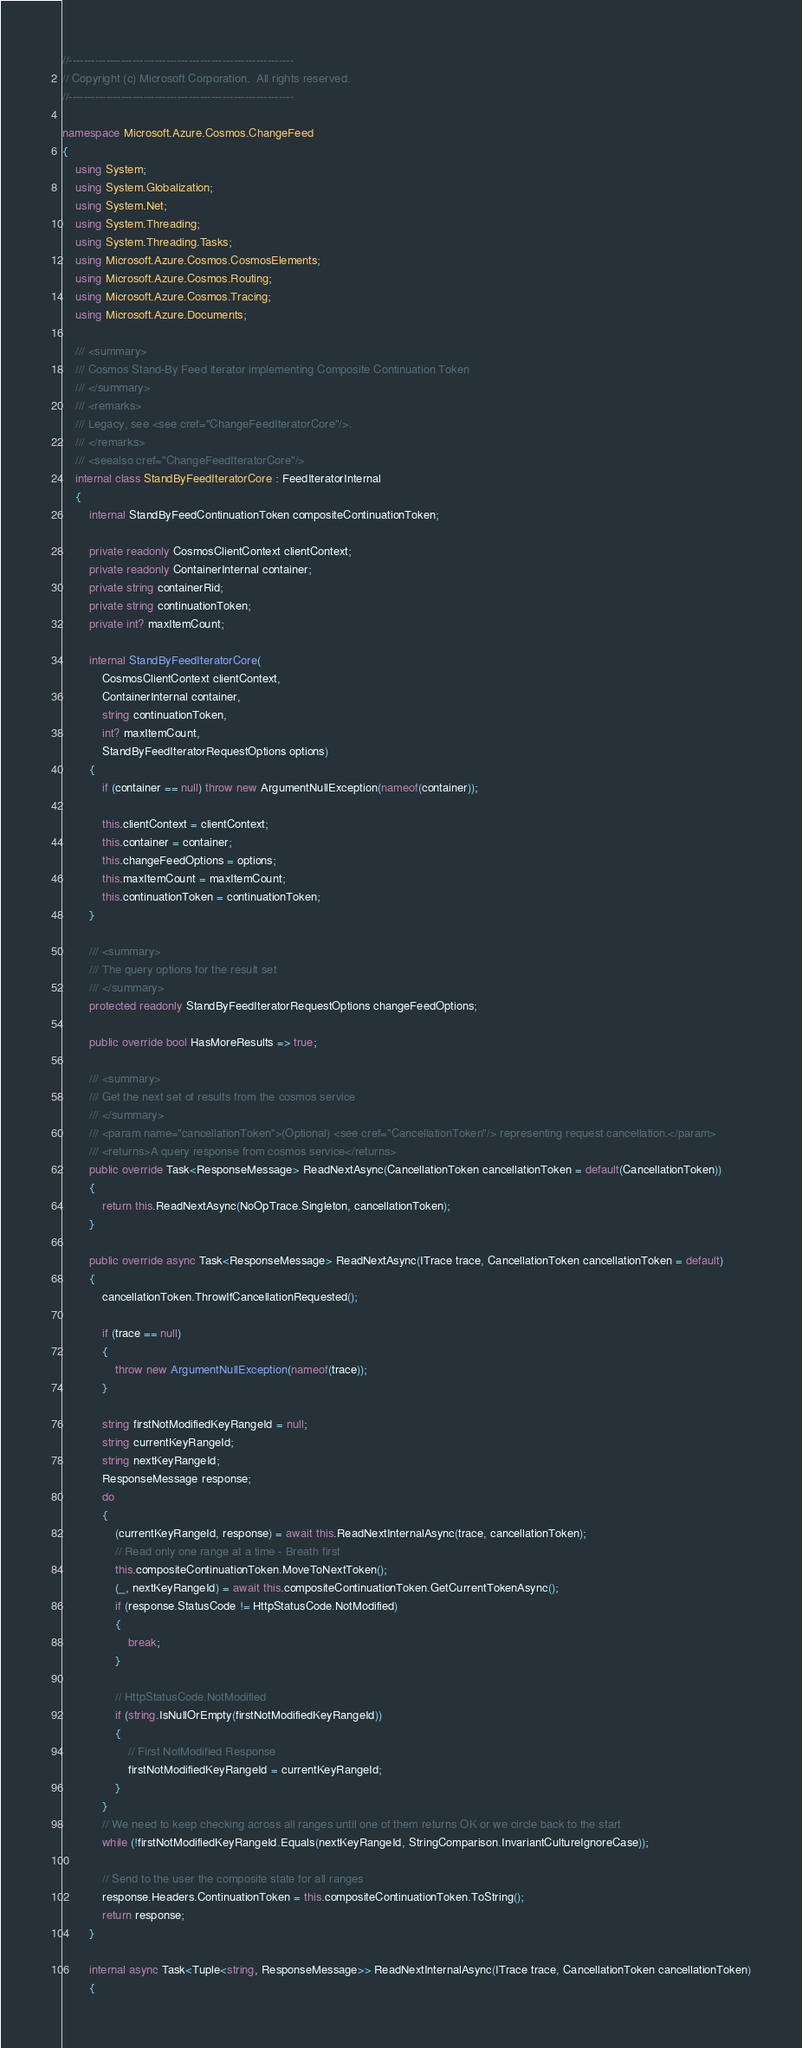Convert code to text. <code><loc_0><loc_0><loc_500><loc_500><_C#_>//------------------------------------------------------------
// Copyright (c) Microsoft Corporation.  All rights reserved.
//------------------------------------------------------------

namespace Microsoft.Azure.Cosmos.ChangeFeed
{
    using System;
    using System.Globalization;
    using System.Net;
    using System.Threading;
    using System.Threading.Tasks;
    using Microsoft.Azure.Cosmos.CosmosElements;
    using Microsoft.Azure.Cosmos.Routing;
    using Microsoft.Azure.Cosmos.Tracing;
    using Microsoft.Azure.Documents;

    /// <summary>
    /// Cosmos Stand-By Feed iterator implementing Composite Continuation Token
    /// </summary>
    /// <remarks>
    /// Legacy, see <see cref="ChangeFeedIteratorCore"/>.
    /// </remarks>
    /// <seealso cref="ChangeFeedIteratorCore"/>
    internal class StandByFeedIteratorCore : FeedIteratorInternal
    {
        internal StandByFeedContinuationToken compositeContinuationToken;

        private readonly CosmosClientContext clientContext;
        private readonly ContainerInternal container;
        private string containerRid;
        private string continuationToken;
        private int? maxItemCount;

        internal StandByFeedIteratorCore(
            CosmosClientContext clientContext,
            ContainerInternal container,
            string continuationToken,
            int? maxItemCount,
            StandByFeedIteratorRequestOptions options)
        {
            if (container == null) throw new ArgumentNullException(nameof(container));

            this.clientContext = clientContext;
            this.container = container;
            this.changeFeedOptions = options;
            this.maxItemCount = maxItemCount;
            this.continuationToken = continuationToken;
        }

        /// <summary>
        /// The query options for the result set
        /// </summary>
        protected readonly StandByFeedIteratorRequestOptions changeFeedOptions;

        public override bool HasMoreResults => true;

        /// <summary>
        /// Get the next set of results from the cosmos service
        /// </summary>
        /// <param name="cancellationToken">(Optional) <see cref="CancellationToken"/> representing request cancellation.</param>
        /// <returns>A query response from cosmos service</returns>
        public override Task<ResponseMessage> ReadNextAsync(CancellationToken cancellationToken = default(CancellationToken))
        {
            return this.ReadNextAsync(NoOpTrace.Singleton, cancellationToken);
        }

        public override async Task<ResponseMessage> ReadNextAsync(ITrace trace, CancellationToken cancellationToken = default)
        {
            cancellationToken.ThrowIfCancellationRequested();

            if (trace == null)
            {
                throw new ArgumentNullException(nameof(trace));
            }

            string firstNotModifiedKeyRangeId = null;
            string currentKeyRangeId;
            string nextKeyRangeId;
            ResponseMessage response;
            do
            {
                (currentKeyRangeId, response) = await this.ReadNextInternalAsync(trace, cancellationToken);
                // Read only one range at a time - Breath first
                this.compositeContinuationToken.MoveToNextToken();
                (_, nextKeyRangeId) = await this.compositeContinuationToken.GetCurrentTokenAsync();
                if (response.StatusCode != HttpStatusCode.NotModified)
                {
                    break;
                }

                // HttpStatusCode.NotModified
                if (string.IsNullOrEmpty(firstNotModifiedKeyRangeId))
                {
                    // First NotModified Response
                    firstNotModifiedKeyRangeId = currentKeyRangeId;
                }
            }
            // We need to keep checking across all ranges until one of them returns OK or we circle back to the start
            while (!firstNotModifiedKeyRangeId.Equals(nextKeyRangeId, StringComparison.InvariantCultureIgnoreCase));

            // Send to the user the composite state for all ranges
            response.Headers.ContinuationToken = this.compositeContinuationToken.ToString();
            return response;
        }

        internal async Task<Tuple<string, ResponseMessage>> ReadNextInternalAsync(ITrace trace, CancellationToken cancellationToken)
        {</code> 